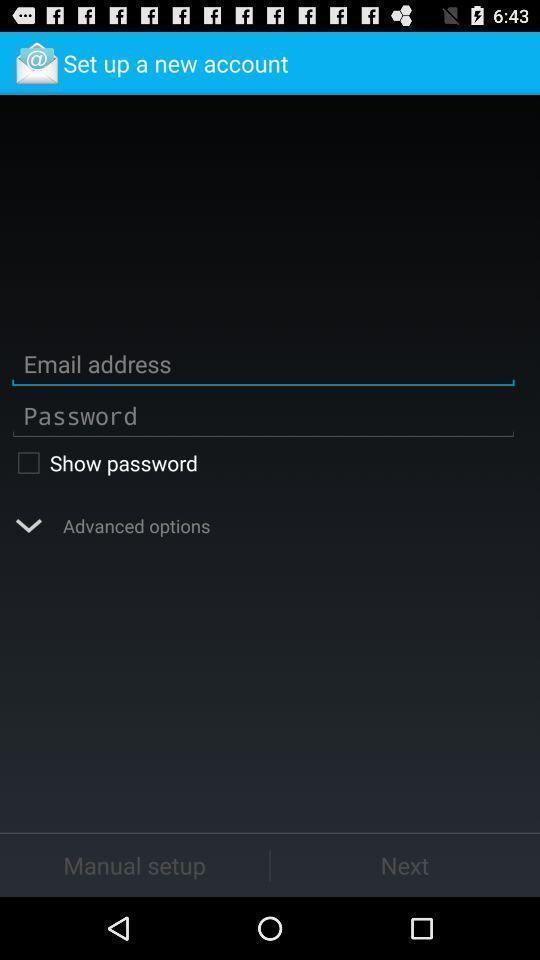What details can you identify in this image? Set up page. 